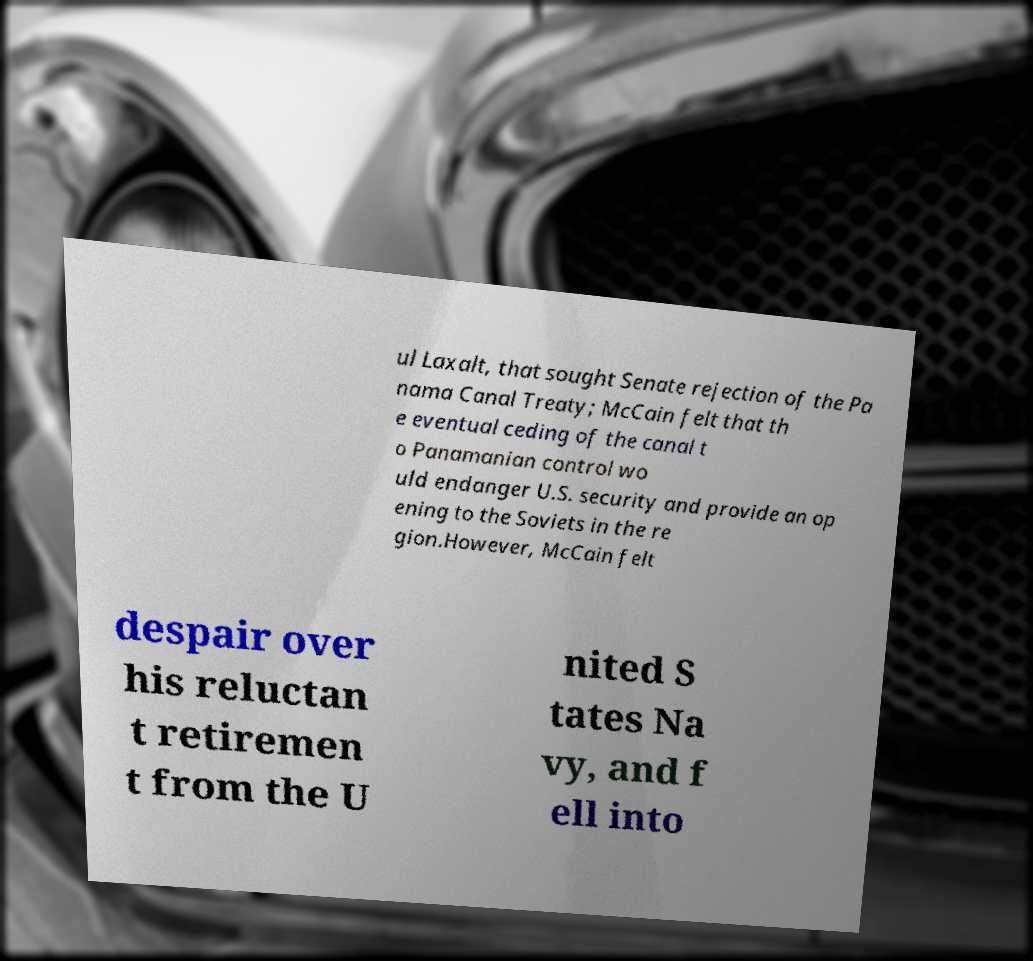Please read and relay the text visible in this image. What does it say? ul Laxalt, that sought Senate rejection of the Pa nama Canal Treaty; McCain felt that th e eventual ceding of the canal t o Panamanian control wo uld endanger U.S. security and provide an op ening to the Soviets in the re gion.However, McCain felt despair over his reluctan t retiremen t from the U nited S tates Na vy, and f ell into 